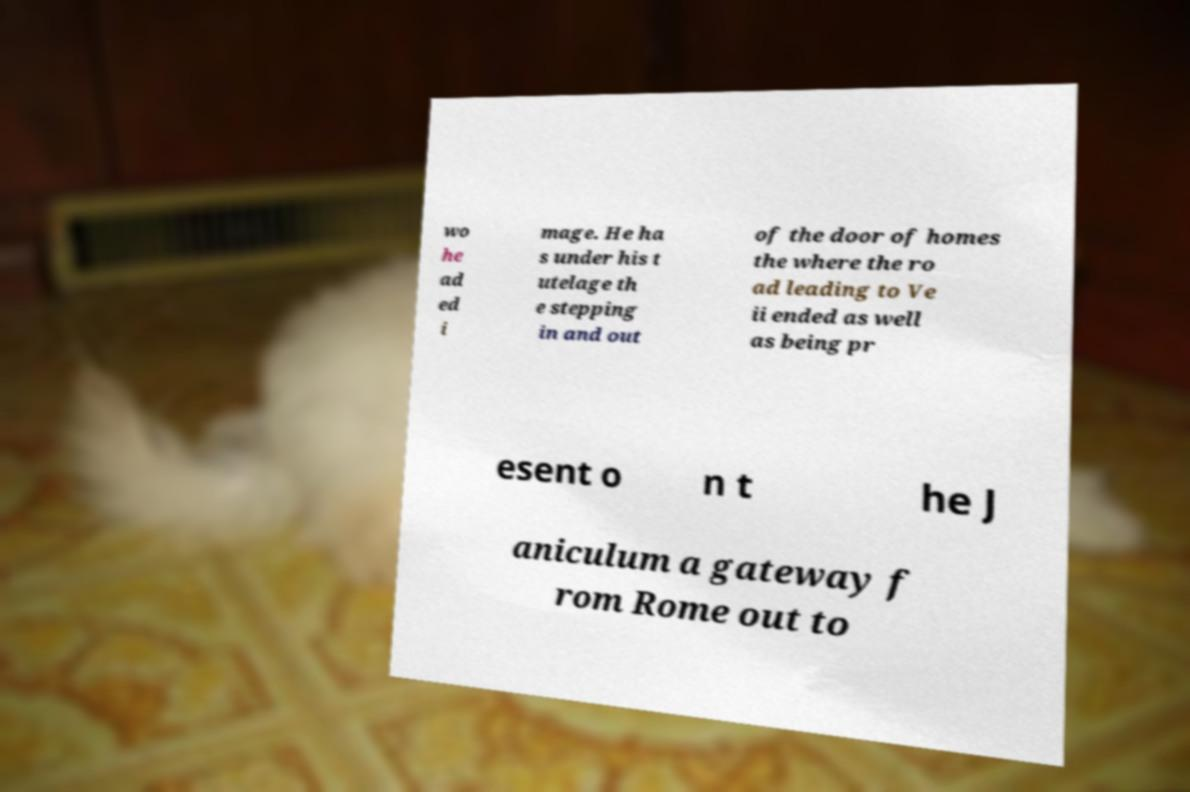There's text embedded in this image that I need extracted. Can you transcribe it verbatim? wo he ad ed i mage. He ha s under his t utelage th e stepping in and out of the door of homes the where the ro ad leading to Ve ii ended as well as being pr esent o n t he J aniculum a gateway f rom Rome out to 